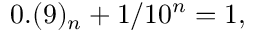Convert formula to latex. <formula><loc_0><loc_0><loc_500><loc_500>0 . ( 9 ) _ { n } + 1 / 1 0 ^ { n } = 1 ,</formula> 